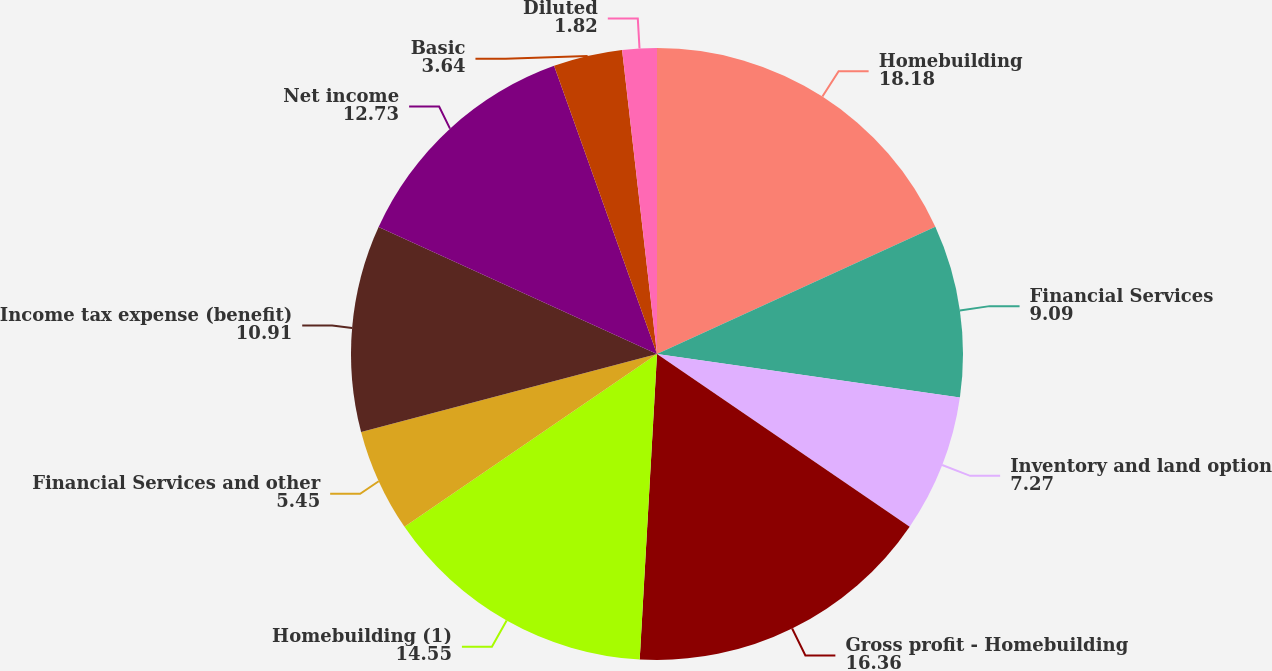Convert chart to OTSL. <chart><loc_0><loc_0><loc_500><loc_500><pie_chart><fcel>Homebuilding<fcel>Financial Services<fcel>Inventory and land option<fcel>Gross profit - Homebuilding<fcel>Homebuilding (1)<fcel>Financial Services and other<fcel>Income tax expense (benefit)<fcel>Net income<fcel>Basic<fcel>Diluted<nl><fcel>18.18%<fcel>9.09%<fcel>7.27%<fcel>16.36%<fcel>14.55%<fcel>5.45%<fcel>10.91%<fcel>12.73%<fcel>3.64%<fcel>1.82%<nl></chart> 